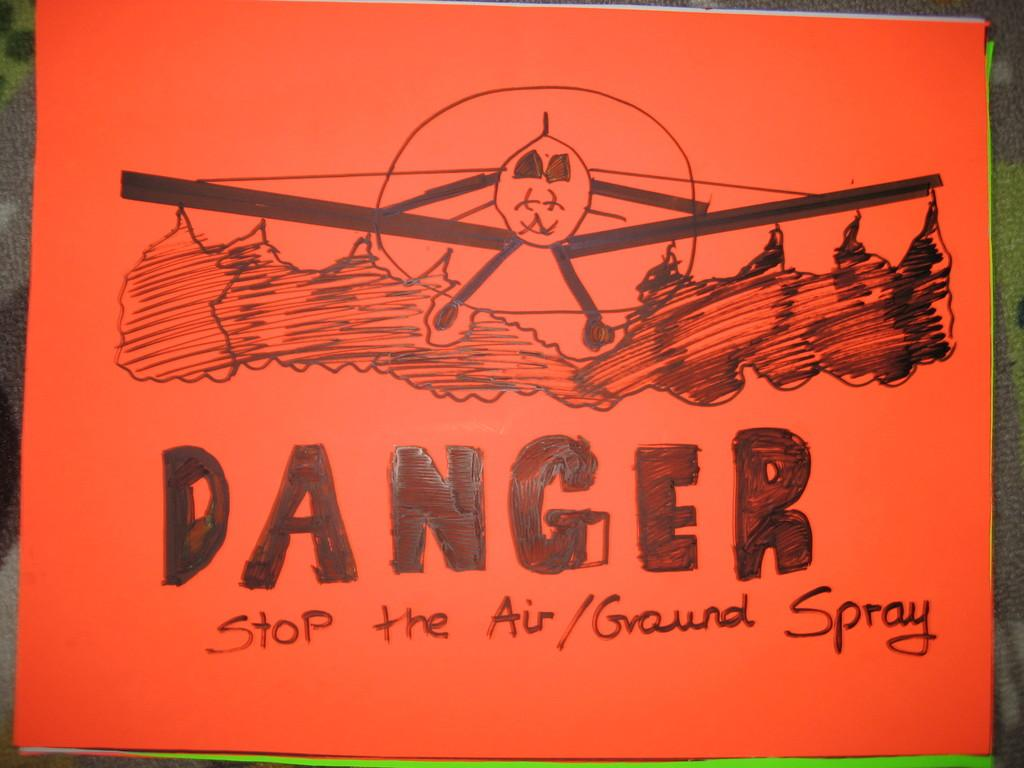<image>
Present a compact description of the photo's key features. A hand drawn sign that says Danger Stop the Air/Ground Spray. 